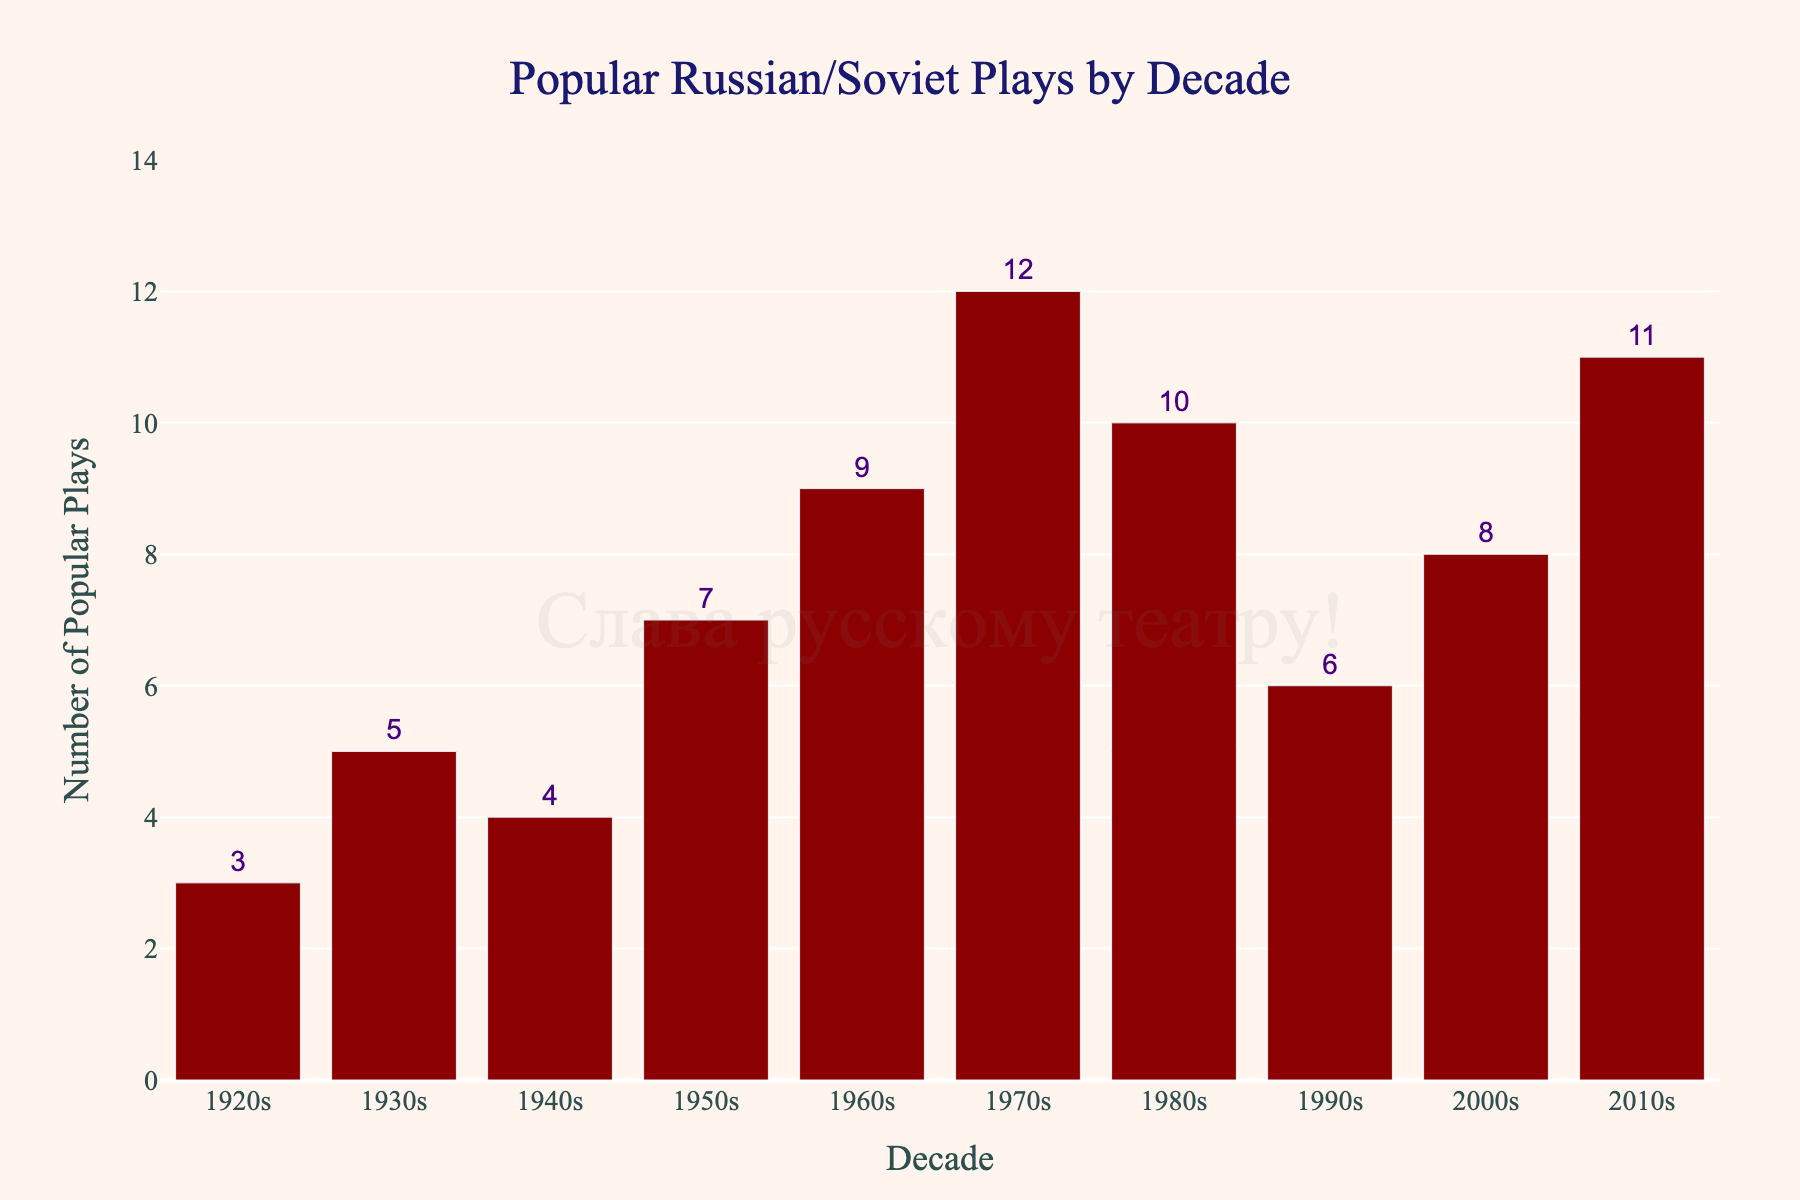Which decade had the highest number of popular Russian/Soviet plays performed? The tallest bar represents the decade with the highest number. The tallest bar is for the 1970s with 12 plays.
Answer: 1970s How many more popular plays were performed in the 2010s compared to the 1990s? The bar for the 2010s shows 11 plays, and the bar for the 1990s shows 6 plays. Subtracting these gives 11 - 6 = 5 more plays.
Answer: 5 What is the total number of popular plays performed during the 20th century (1920s to 1990s)? Add the number of popular plays from each decade in the 20th century: 3 + 5 + 4 + 7 + 9 + 12 + 10 + 6 = 56 plays.
Answer: 56 What is the average number of popular plays performed per decade from 1920s to 2010s? Sum the number of popular plays for each decade and divide by the number of decades: (3 + 5 + 4 + 7 + 9 + 12 + 10 + 6 + 8 + 11) / 10. The total is 75, and 75/10 = 7.5.
Answer: 7.5 Which decade had the lowest number of popular plays performed and how many were there? The shortest bar represents the decade with the lowest number. The shortest bar is for the 1920s with 3 plays.
Answer: 1920s, 3 What is the difference in the number of popular plays performed between the 1980s and the 1990s? The bar for the 1980s shows 10 plays, and the bar for the 1990s shows 6 plays. Subtracting these gives 10 - 6 = 4 more plays.
Answer: 4 How many total popular plays were performed from 2000s to 2010s? Add the number of popular plays from the 2000s and 2010s: 8 + 11 = 19 plays.
Answer: 19 